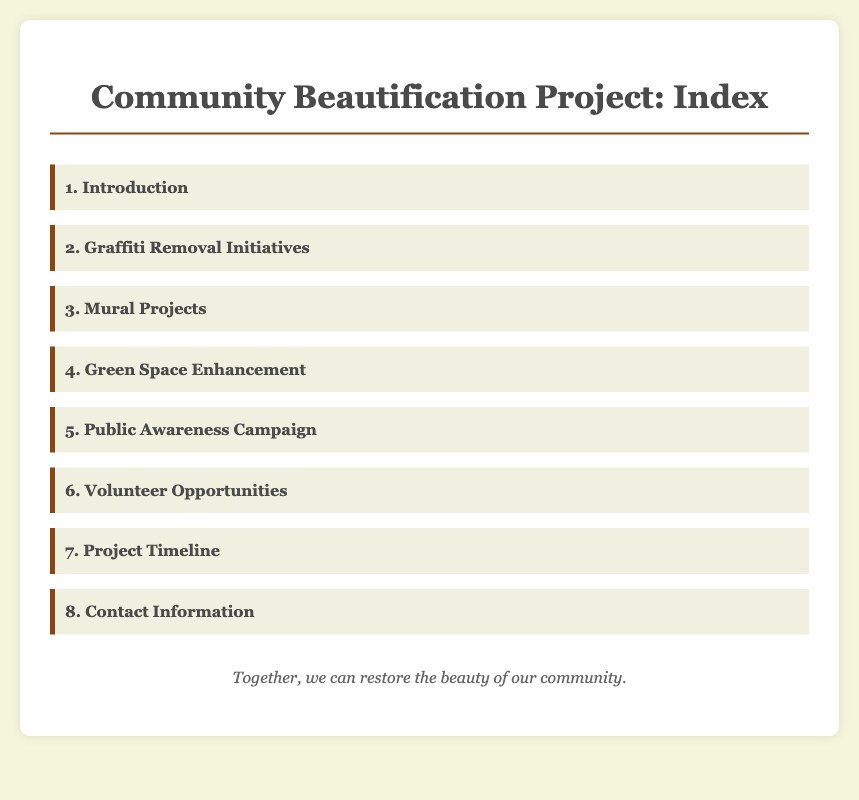What is the title of the project? The title of the project, as stated at the top of the document, is "Community Beautification Project: Index."
Answer: Community Beautification Project: Index What is the first item in the index? The first item in the index is outlined in the document as "1. Introduction."
Answer: 1. Introduction How many volunteer opportunities are mentioned? The number of volunteer opportunities can be found in the index as the sixth item, which is titled "6. Volunteer Opportunities."
Answer: 6 What is the focus of the second section? The second section is focused on initiatives to address a specific concern, which is "Graffiti Removal Initiatives."
Answer: Graffiti Removal Initiatives Which aspect of the community enhancement is listed fourth? The fourth item in the index highlights an important area of focus regarding community beautification, which is "Green Space Enhancement."
Answer: Green Space Enhancement What is the purpose of the public awareness campaign? Based on the index, the fifth item suggests that the purpose is to promote community engagement and understanding, referred to as "Public Awareness Campaign."
Answer: Public Awareness Campaign What does the footer emphasize? The footer contains a motivational phrase aimed at encouraging community participation, stating that "Together, we can restore the beauty of our community."
Answer: Together, we can restore the beauty of our community What type of content layout does the document follow? The layout contains an organized set of headings and links, specifically in the format of an index.
Answer: Index 